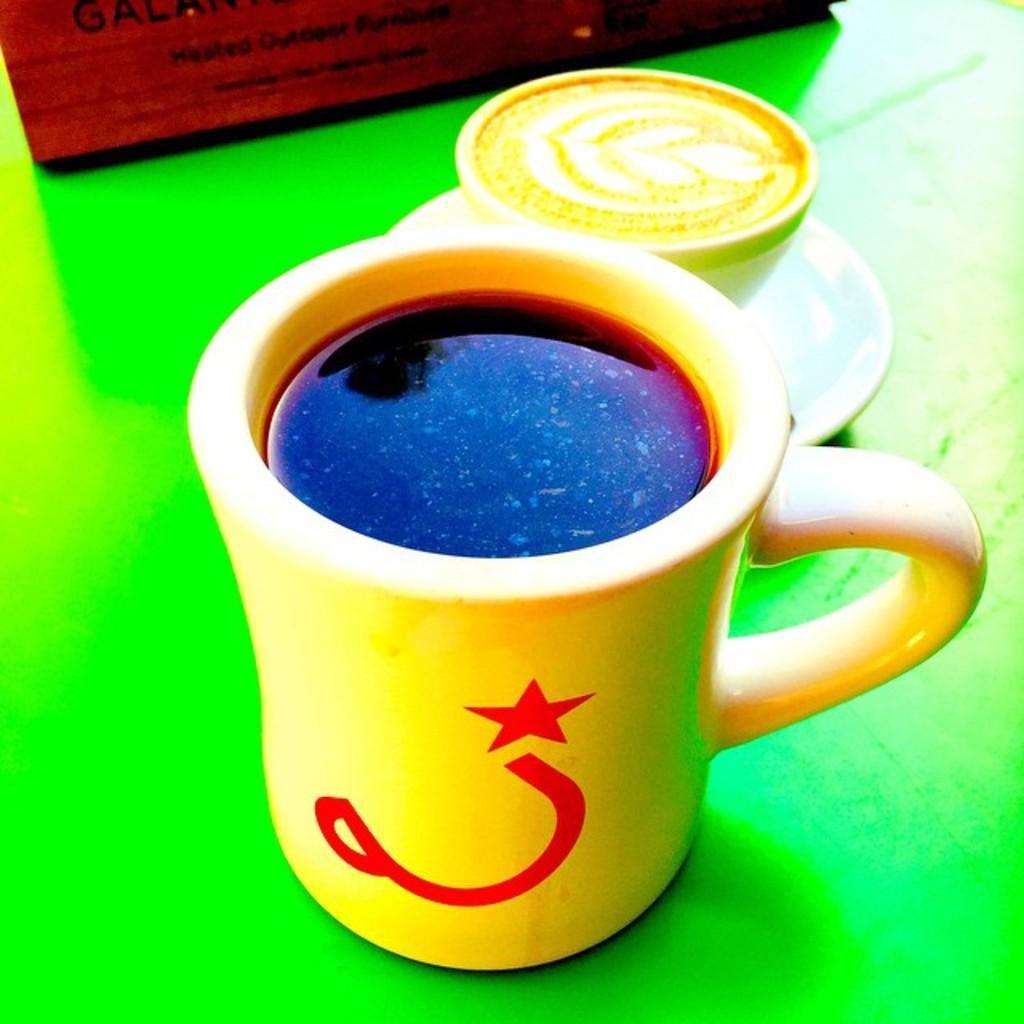Describe this image in one or two sentences. In the center of the image there are two cups on the green color surface. 